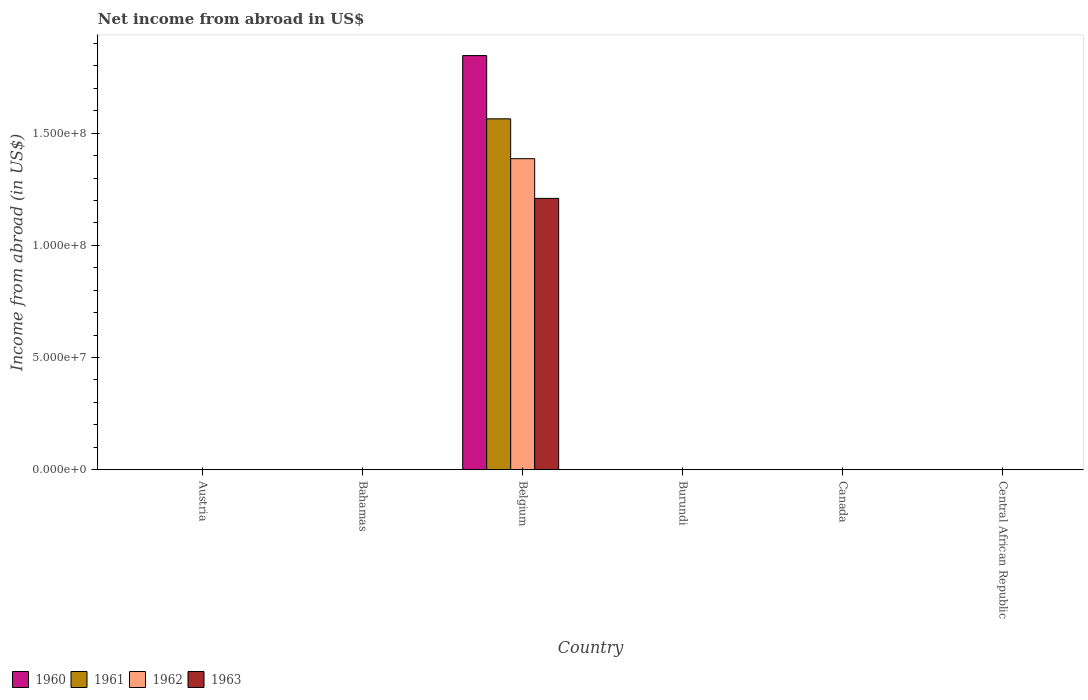Are the number of bars on each tick of the X-axis equal?
Keep it short and to the point. No. How many bars are there on the 4th tick from the right?
Your response must be concise. 4. What is the label of the 1st group of bars from the left?
Give a very brief answer. Austria. What is the net income from abroad in 1963 in Belgium?
Your response must be concise. 1.21e+08. Across all countries, what is the maximum net income from abroad in 1963?
Provide a short and direct response. 1.21e+08. Across all countries, what is the minimum net income from abroad in 1960?
Offer a very short reply. 0. What is the total net income from abroad in 1963 in the graph?
Your response must be concise. 1.21e+08. What is the difference between the net income from abroad in 1961 in Belgium and the net income from abroad in 1963 in Canada?
Offer a very short reply. 1.56e+08. What is the average net income from abroad in 1961 per country?
Offer a terse response. 2.61e+07. What is the difference between the net income from abroad of/in 1962 and net income from abroad of/in 1963 in Belgium?
Offer a very short reply. 1.77e+07. In how many countries, is the net income from abroad in 1963 greater than 90000000 US$?
Offer a terse response. 1. What is the difference between the highest and the lowest net income from abroad in 1962?
Ensure brevity in your answer.  1.39e+08. In how many countries, is the net income from abroad in 1962 greater than the average net income from abroad in 1962 taken over all countries?
Your answer should be compact. 1. Is it the case that in every country, the sum of the net income from abroad in 1960 and net income from abroad in 1963 is greater than the sum of net income from abroad in 1961 and net income from abroad in 1962?
Provide a succinct answer. No. How many bars are there?
Your answer should be very brief. 4. How many countries are there in the graph?
Provide a short and direct response. 6. What is the difference between two consecutive major ticks on the Y-axis?
Provide a short and direct response. 5.00e+07. Are the values on the major ticks of Y-axis written in scientific E-notation?
Your answer should be compact. Yes. Does the graph contain any zero values?
Your answer should be very brief. Yes. Does the graph contain grids?
Keep it short and to the point. No. Where does the legend appear in the graph?
Offer a very short reply. Bottom left. What is the title of the graph?
Your answer should be very brief. Net income from abroad in US$. Does "1965" appear as one of the legend labels in the graph?
Ensure brevity in your answer.  No. What is the label or title of the X-axis?
Make the answer very short. Country. What is the label or title of the Y-axis?
Offer a terse response. Income from abroad (in US$). What is the Income from abroad (in US$) of 1961 in Austria?
Ensure brevity in your answer.  0. What is the Income from abroad (in US$) in 1960 in Bahamas?
Ensure brevity in your answer.  0. What is the Income from abroad (in US$) in 1961 in Bahamas?
Keep it short and to the point. 0. What is the Income from abroad (in US$) of 1963 in Bahamas?
Your response must be concise. 0. What is the Income from abroad (in US$) of 1960 in Belgium?
Your answer should be compact. 1.85e+08. What is the Income from abroad (in US$) in 1961 in Belgium?
Give a very brief answer. 1.56e+08. What is the Income from abroad (in US$) of 1962 in Belgium?
Provide a short and direct response. 1.39e+08. What is the Income from abroad (in US$) of 1963 in Belgium?
Ensure brevity in your answer.  1.21e+08. What is the Income from abroad (in US$) of 1960 in Burundi?
Your answer should be compact. 0. What is the Income from abroad (in US$) in 1962 in Burundi?
Keep it short and to the point. 0. What is the Income from abroad (in US$) of 1961 in Canada?
Make the answer very short. 0. What is the Income from abroad (in US$) in 1962 in Canada?
Provide a short and direct response. 0. What is the Income from abroad (in US$) in 1963 in Canada?
Your answer should be compact. 0. What is the Income from abroad (in US$) of 1960 in Central African Republic?
Keep it short and to the point. 0. What is the Income from abroad (in US$) in 1963 in Central African Republic?
Make the answer very short. 0. Across all countries, what is the maximum Income from abroad (in US$) in 1960?
Ensure brevity in your answer.  1.85e+08. Across all countries, what is the maximum Income from abroad (in US$) of 1961?
Ensure brevity in your answer.  1.56e+08. Across all countries, what is the maximum Income from abroad (in US$) of 1962?
Give a very brief answer. 1.39e+08. Across all countries, what is the maximum Income from abroad (in US$) of 1963?
Your answer should be compact. 1.21e+08. What is the total Income from abroad (in US$) of 1960 in the graph?
Your response must be concise. 1.85e+08. What is the total Income from abroad (in US$) of 1961 in the graph?
Offer a very short reply. 1.56e+08. What is the total Income from abroad (in US$) of 1962 in the graph?
Provide a succinct answer. 1.39e+08. What is the total Income from abroad (in US$) of 1963 in the graph?
Provide a short and direct response. 1.21e+08. What is the average Income from abroad (in US$) in 1960 per country?
Give a very brief answer. 3.08e+07. What is the average Income from abroad (in US$) in 1961 per country?
Keep it short and to the point. 2.61e+07. What is the average Income from abroad (in US$) in 1962 per country?
Make the answer very short. 2.31e+07. What is the average Income from abroad (in US$) in 1963 per country?
Provide a short and direct response. 2.02e+07. What is the difference between the Income from abroad (in US$) in 1960 and Income from abroad (in US$) in 1961 in Belgium?
Your answer should be compact. 2.82e+07. What is the difference between the Income from abroad (in US$) in 1960 and Income from abroad (in US$) in 1962 in Belgium?
Give a very brief answer. 4.60e+07. What is the difference between the Income from abroad (in US$) of 1960 and Income from abroad (in US$) of 1963 in Belgium?
Ensure brevity in your answer.  6.37e+07. What is the difference between the Income from abroad (in US$) in 1961 and Income from abroad (in US$) in 1962 in Belgium?
Your answer should be very brief. 1.78e+07. What is the difference between the Income from abroad (in US$) of 1961 and Income from abroad (in US$) of 1963 in Belgium?
Offer a very short reply. 3.55e+07. What is the difference between the Income from abroad (in US$) of 1962 and Income from abroad (in US$) of 1963 in Belgium?
Keep it short and to the point. 1.77e+07. What is the difference between the highest and the lowest Income from abroad (in US$) of 1960?
Your answer should be very brief. 1.85e+08. What is the difference between the highest and the lowest Income from abroad (in US$) in 1961?
Keep it short and to the point. 1.56e+08. What is the difference between the highest and the lowest Income from abroad (in US$) of 1962?
Your answer should be compact. 1.39e+08. What is the difference between the highest and the lowest Income from abroad (in US$) of 1963?
Keep it short and to the point. 1.21e+08. 